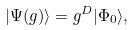<formula> <loc_0><loc_0><loc_500><loc_500>| \Psi ( g ) \rangle = g ^ { D } | \Phi _ { 0 } \rangle ,</formula> 